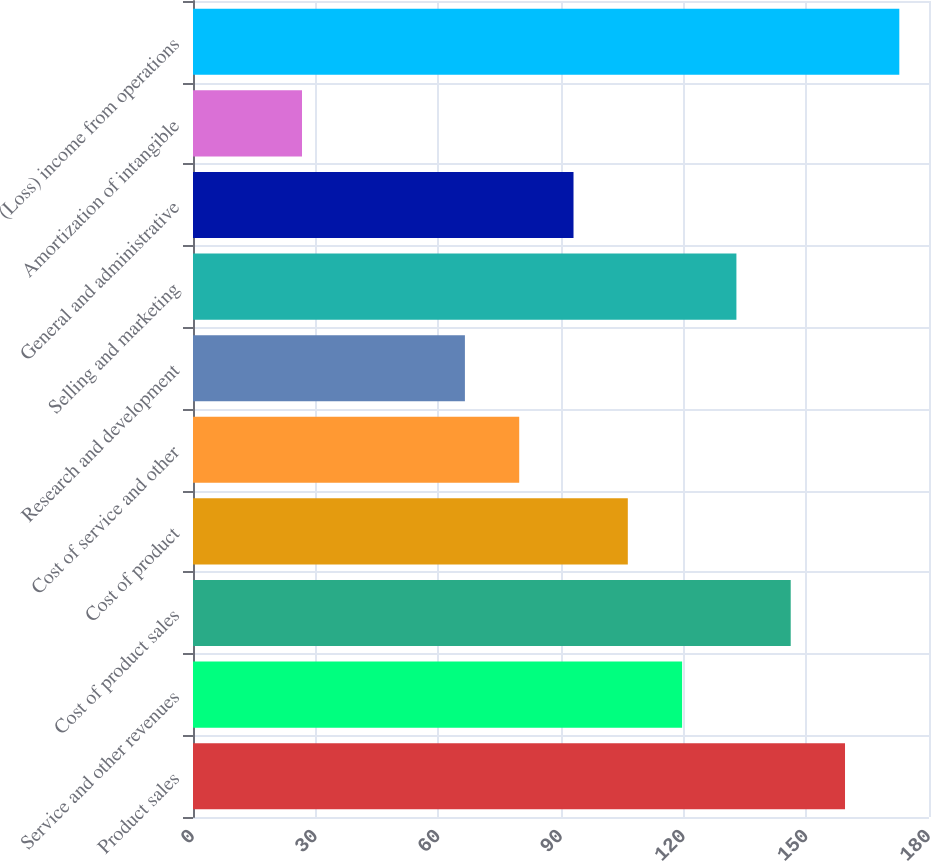Convert chart to OTSL. <chart><loc_0><loc_0><loc_500><loc_500><bar_chart><fcel>Product sales<fcel>Service and other revenues<fcel>Cost of product sales<fcel>Cost of product<fcel>Cost of service and other<fcel>Research and development<fcel>Selling and marketing<fcel>General and administrative<fcel>Amortization of intangible<fcel>(Loss) income from operations<nl><fcel>159.46<fcel>119.62<fcel>146.18<fcel>106.34<fcel>79.78<fcel>66.5<fcel>132.9<fcel>93.06<fcel>26.66<fcel>172.74<nl></chart> 